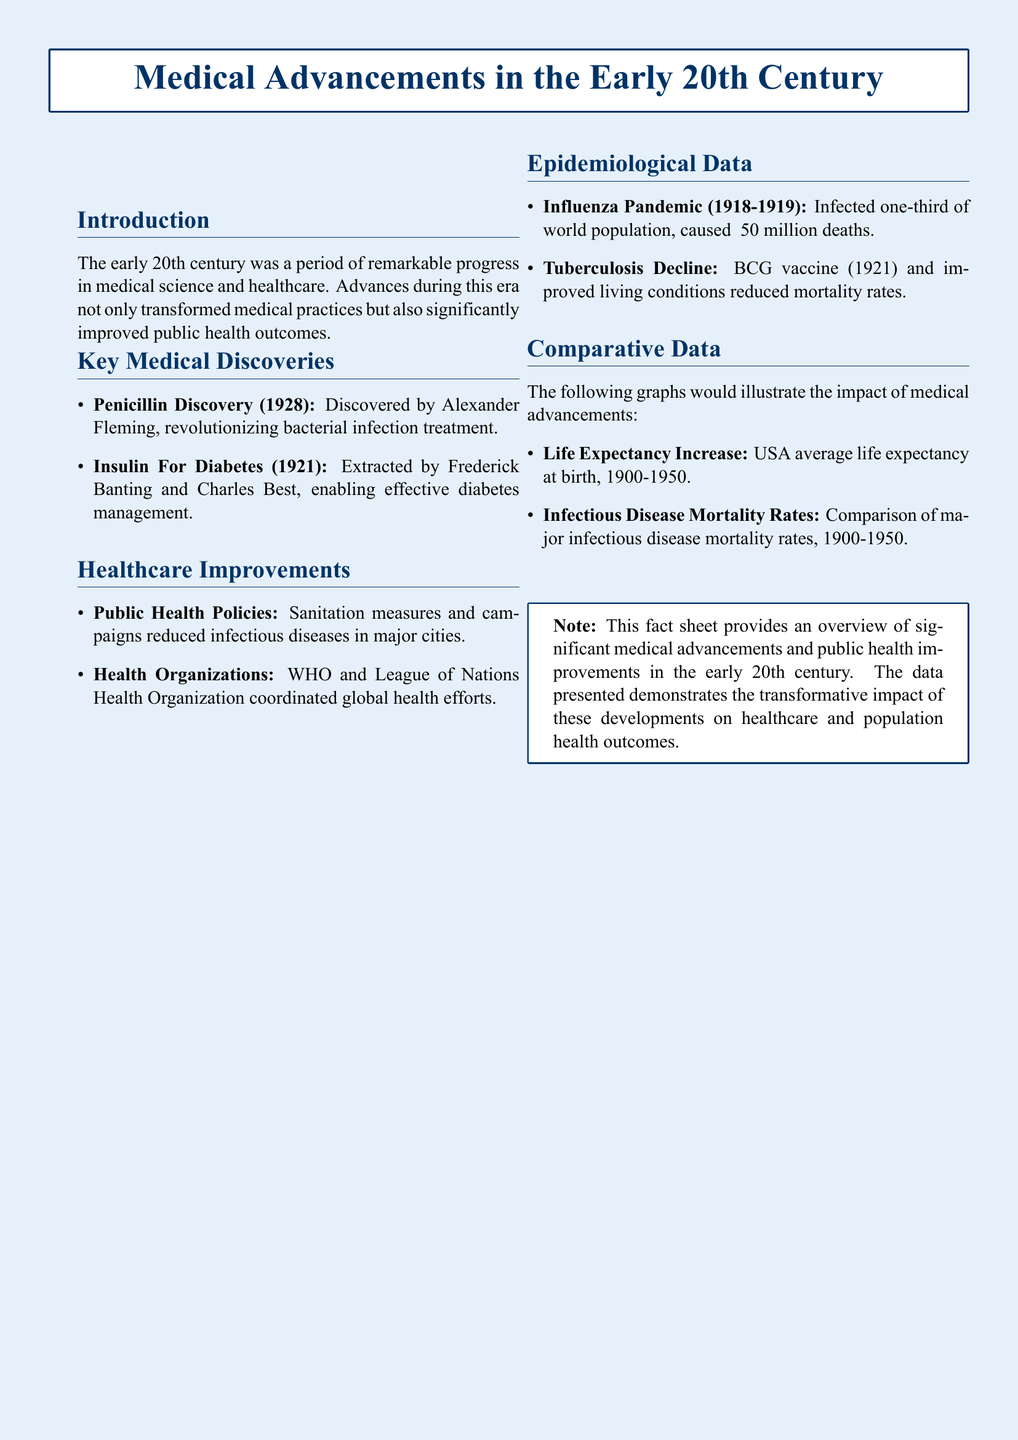What year was penicillin discovered? The document states that penicillin was discovered in 1928 by Alexander Fleming.
Answer: 1928 Who were the discoverers of insulin? The document mentions that insulin was extracted by Frederick Banting and Charles Best.
Answer: Frederick Banting and Charles Best What significant public health measure is noted in the document? The document lists sanitation measures and campaigns that reduced infectious diseases.
Answer: Sanitation measures What was the impact of the influenza pandemic according to the document? The document reports that the influenza pandemic infected one-third of the world population and caused approximately 50 million deaths.
Answer: ~50 million deaths What vaccine contributed to the decline of tuberculosis? The document highlights the BCG vaccine introduced in 1921 as significant for tuberculosis decline.
Answer: BCG vaccine What does the document indicate about life expectancy trends? The document states that there is a graph illustrating the increase in life expectancy in the USA at birth from 1900-1950.
Answer: Increase in life expectancy What health organization is mentioned in relation to global health efforts? The document indicates that WHO and the League of Nations Health Organization played roles in coordinating global health efforts.
Answer: WHO What major health improvement is discussed in the document regarding infectious diseases? The document states that improved living conditions and public health policies contributed to the reduction of infectious diseases.
Answer: Reduction of infectious diseases 